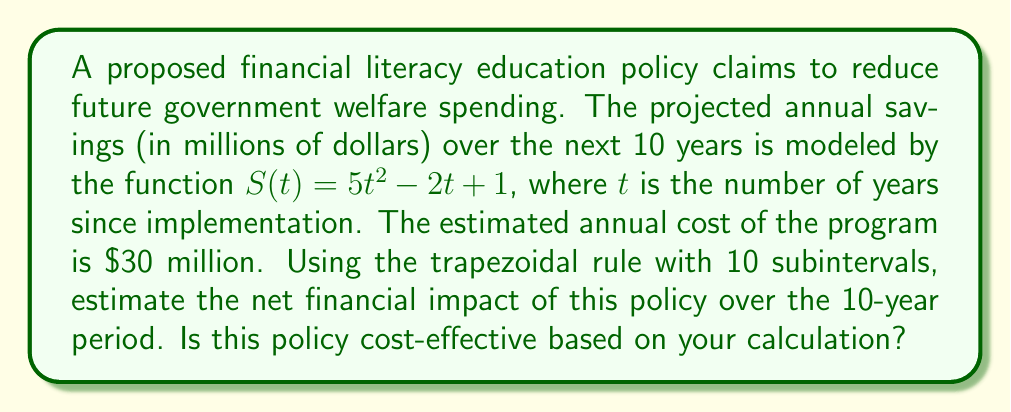Can you solve this math problem? To solve this problem, we'll follow these steps:

1) The trapezoidal rule for numerical integration is given by:

   $$\int_{a}^{b} f(x) dx \approx \frac{h}{2} [f(x_0) + 2f(x_1) + 2f(x_2) + ... + 2f(x_{n-1}) + f(x_n)]$$

   where $h = \frac{b-a}{n}$, $n$ is the number of subintervals, and $x_i = a + ih$.

2) In our case, $a=0$, $b=10$, $n=10$, so $h = 1$.

3) We need to calculate $S(t)$ for $t = 0, 1, 2, ..., 10$:

   $S(0) = 1$
   $S(1) = 5 - 2 + 1 = 4$
   $S(2) = 20 - 4 + 1 = 17$
   $S(3) = 45 - 6 + 1 = 40$
   $S(4) = 80 - 8 + 1 = 73$
   $S(5) = 125 - 10 + 1 = 116$
   $S(6) = 180 - 12 + 1 = 169$
   $S(7) = 245 - 14 + 1 = 232$
   $S(8) = 320 - 16 + 1 = 305$
   $S(9) = 405 - 18 + 1 = 388$
   $S(10) = 500 - 20 + 1 = 481$

4) Applying the trapezoidal rule:

   $$\text{Total Savings} \approx \frac{1}{2} [1 + 2(4 + 17 + 40 + 73 + 116 + 169 + 232 + 305 + 388) + 481]$$
   $$= \frac{1}{2} [1 + 2(1344) + 481] = \frac{1}{2} [2689] = 1344.5$$

5) The total savings over 10 years is approximately $1,344.5 million.

6) The total cost over 10 years is $30 million * 10 = $300 million.

7) The net financial impact is $1,344.5 - 300 = $1,044.5 million.

Since the net financial impact is positive and substantial, this policy appears to be cost-effective based on this calculation.
Answer: $1,044.5 million; Yes, cost-effective 